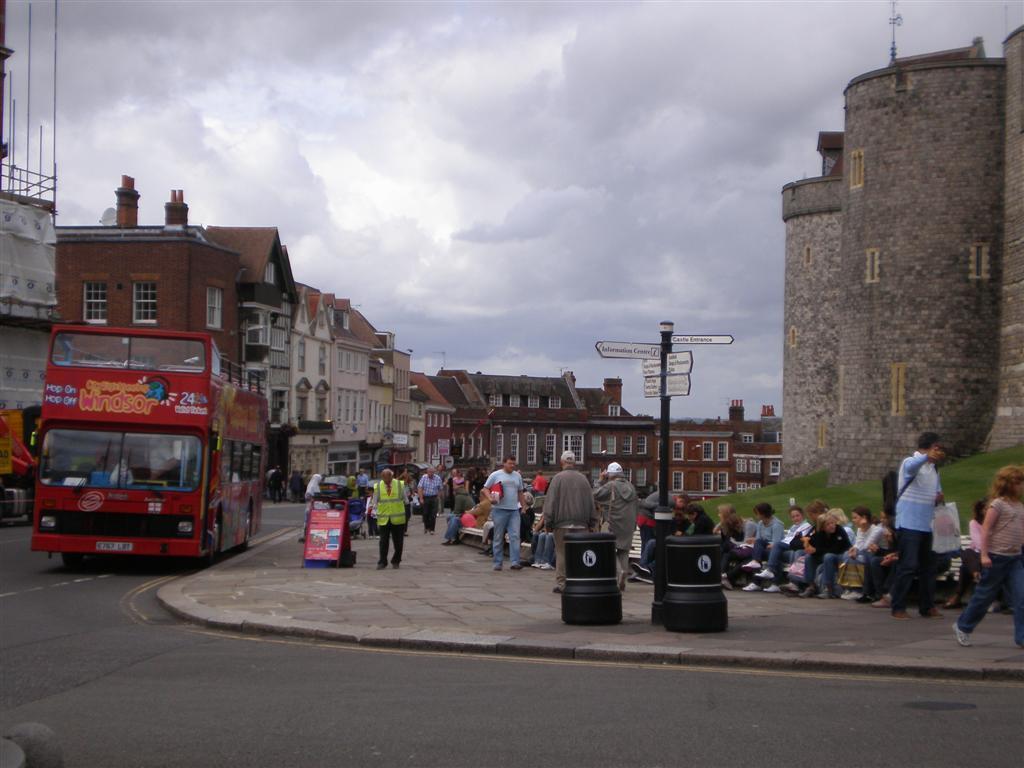Describe this image in one or two sentences. In this image we can see some buildings, a group of houses with roof, a bus on the road, some containers, boards, grass, some metal poles, a signboard and a group of people on the footpath. On the backside we can see the sky which looks cloudy. 